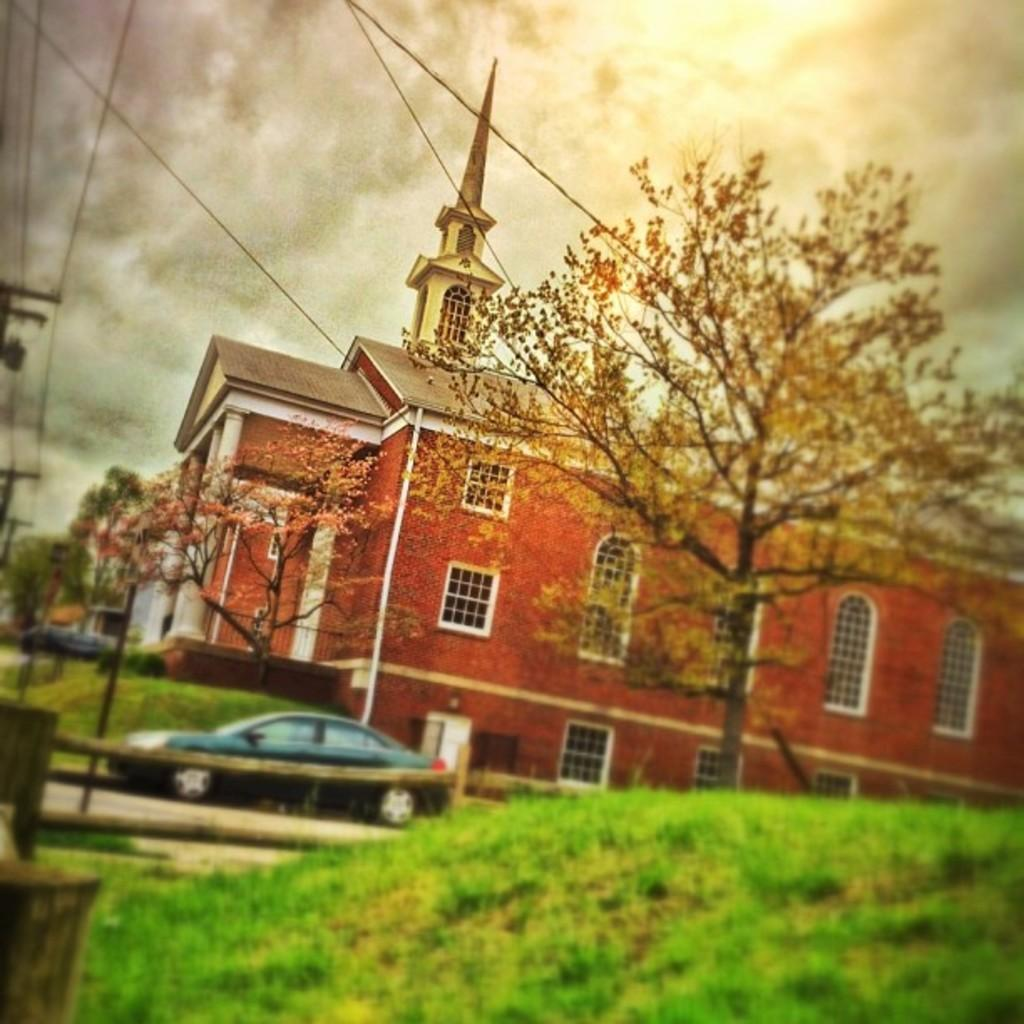What type of surface is at the bottom of the image? There is grass on the ground at the bottom of the image. What can be seen in the background of the image? In the background of the image, there is a fence, a vehicle on the road, trees, buildings, windows, electric poles, wires, and clouds in the sky. Can you describe the type of environment depicted in the image? The image shows a grassy area with a fence, trees, and buildings in the background, along with various man-made structures such as electric poles and wires. Where is the tent located in the image? There is no tent present in the image. What is the condition of the person's knee in the image? There are no people or knees visible in the image. 